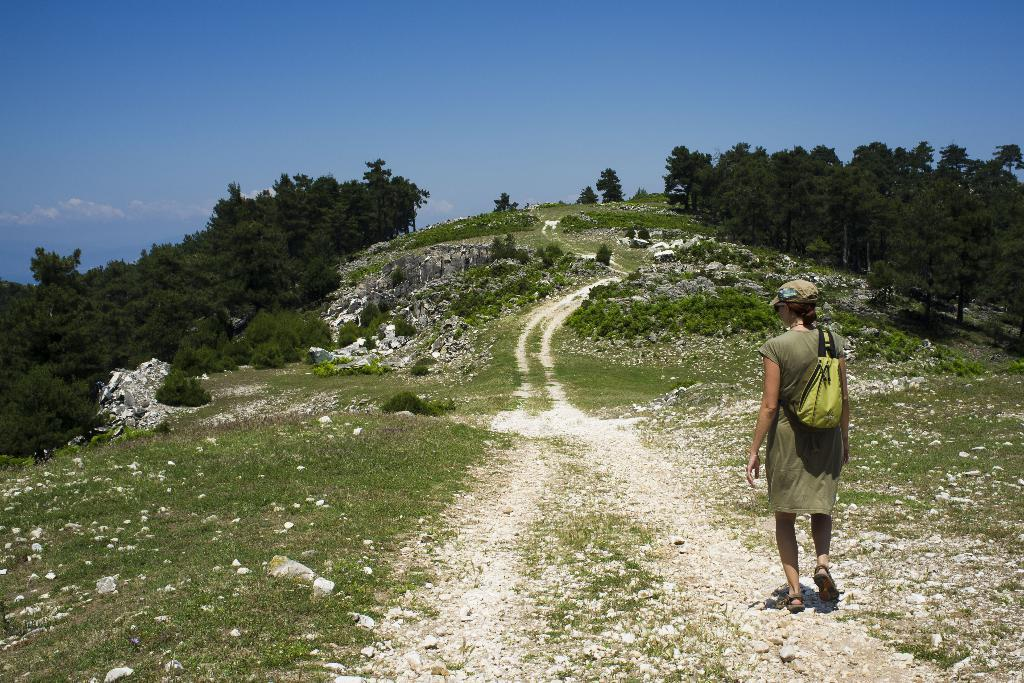What is the person in the image doing? The person is walking in the image. What type of vegetation is in front of the person? There is grass, bushes, rocks, and trees in front of the person. What is visible at the top of the image? The sky is visible at the top of the image. What can be seen in the sky? There are clouds in the sky. Where is the mitten located in the image? There is no mitten present in the image. How many ladybugs can be seen on the rocks in the image? There are no ladybugs visible in the image; only rocks, grass, bushes, and trees are present. 